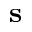<formula> <loc_0><loc_0><loc_500><loc_500>s</formula> 